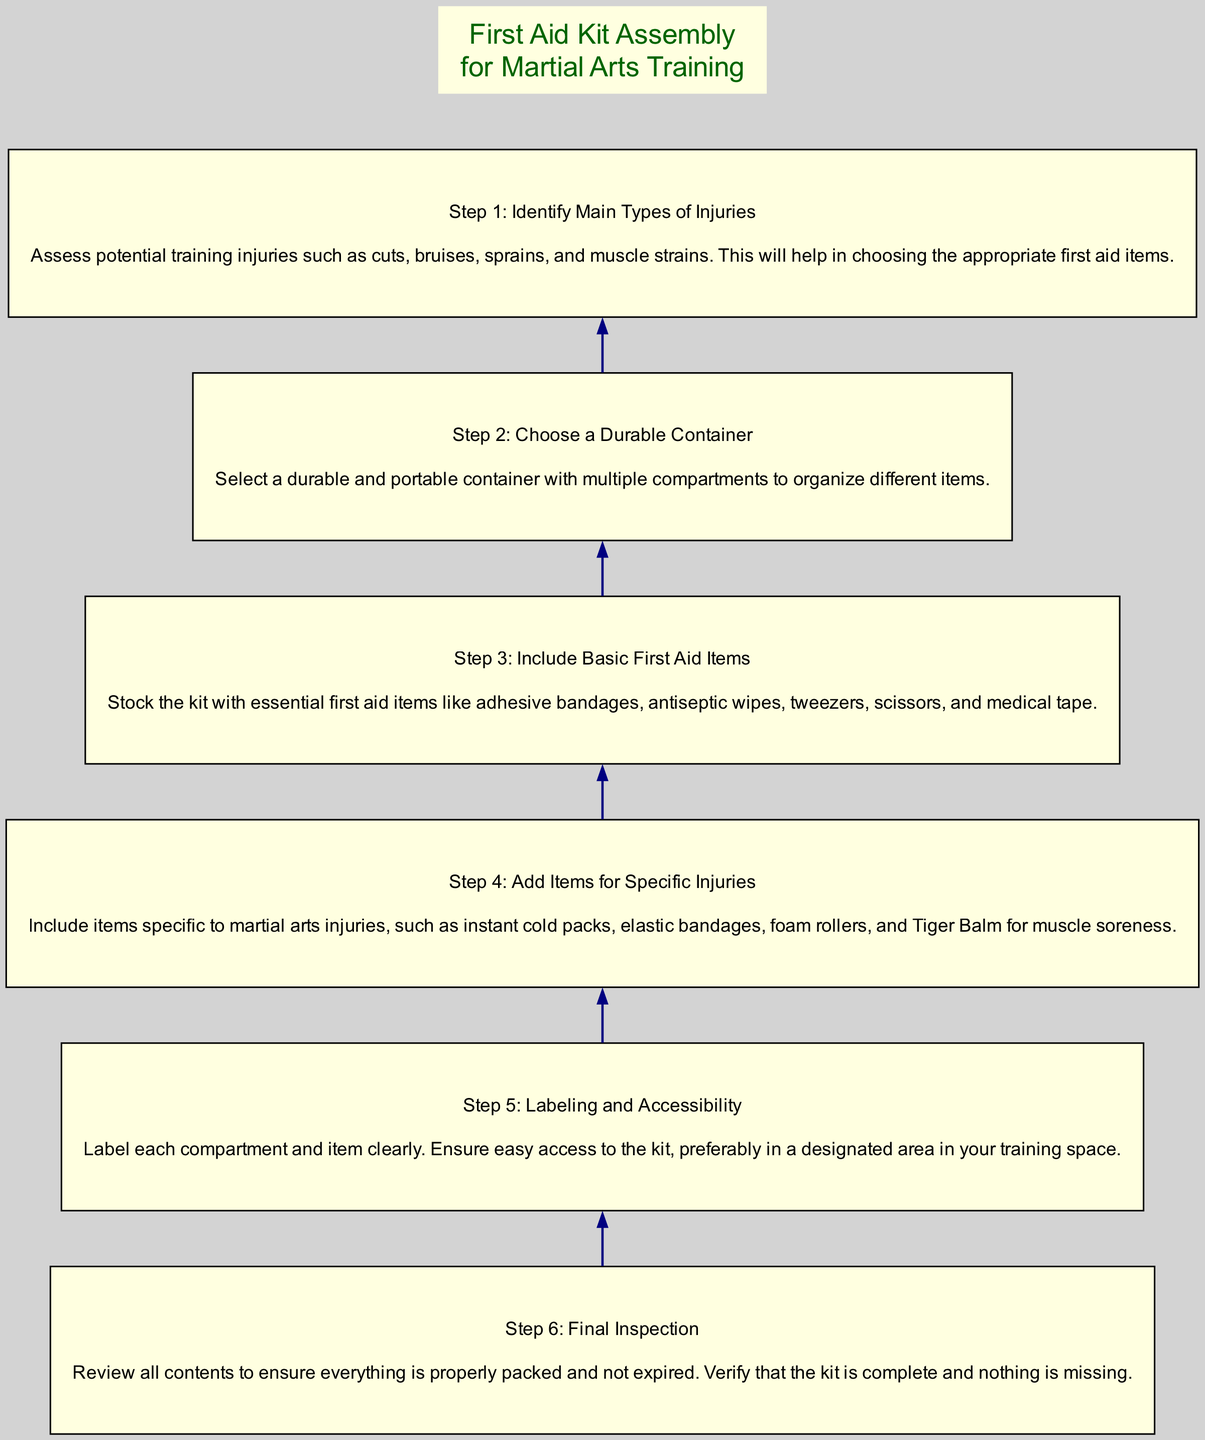What is the first step in assembling the kit? The diagram shows that the first step is to identify the main types of injuries. This is clearly labeled as Step 1 at the bottom of the chart.
Answer: Identify Main Types of Injuries How many steps are there in total? Counting the nodes from the diagram, we find there are six distinct steps presented sequentially in the flow.
Answer: Six What is the last step of the assembly process? The last step is labeled as Step 6, which is the final inspection, indicating the last action in the process outlined in the diagram.
Answer: Final Inspection Which step includes adding items specific to martial arts injuries? In the flow chart, Step 4 is explicitly dedicated to adding specific items for martial arts injuries. This is the clear designation in the sequence.
Answer: Add Items for Specific Injuries What should be done before labeling the kit? According to the flow of steps in the diagram, the action before labeling the kit is to perform a final inspection, as indicated by the sequential flow leading up to Step 5.
Answer: Final Inspection What type of container is recommended for the first aid kit? The diagram proposes choosing a durable container in Step 2, specifying the qualities that the container should possess for effective organization.
Answer: Durable Container What items should be included in the basic first aid category? Step 3 outlines that essential first aid items like adhesive bandages, antiseptic wipes, tweezers, scissors, and medical tape should be stocked in the kit.
Answer: Basic First Aid Items In which step is accessibility emphasized? The diagram highlights accessibility in Step 5, where it instructs on labeling and ensuring that the first aid kit is easy to access in the designated training area.
Answer: Labeling and Accessibility What is the key assessment before choosing items for the kit? Step 1 emphasizes that assessing potential training injuries is crucial for identifying the appropriate first aid items to include in the kit.
Answer: Assess Potential Training Injuries 